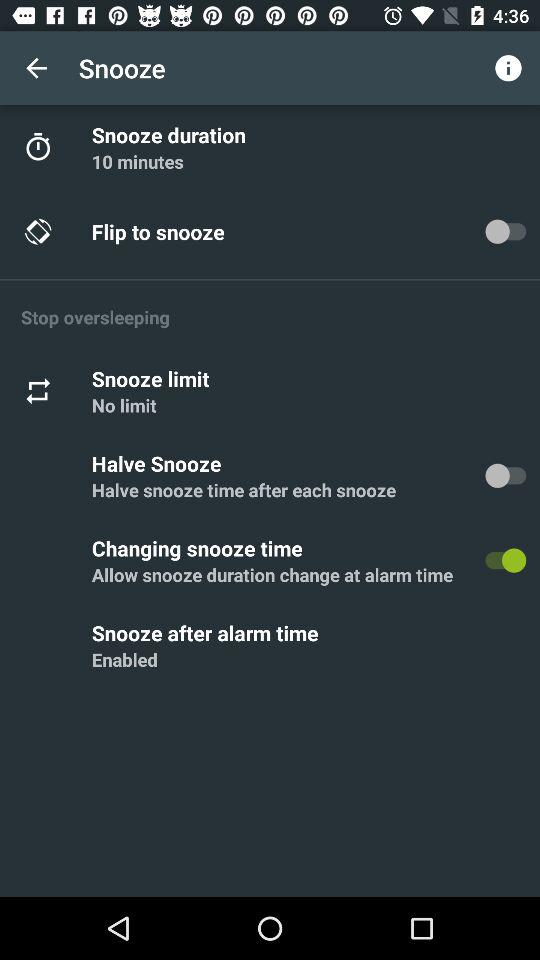What is the status of the changing snooze time? The status is on. 